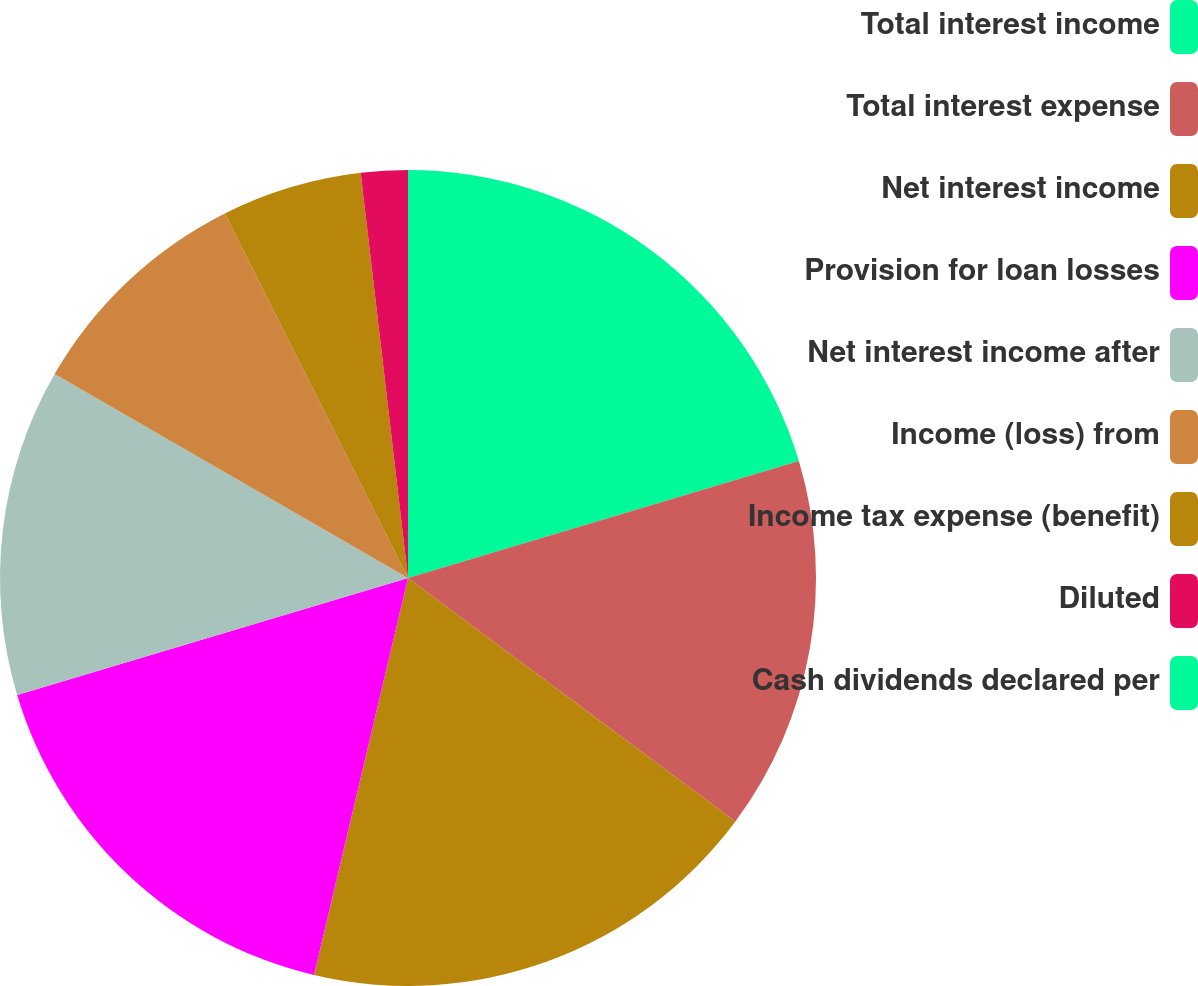Convert chart to OTSL. <chart><loc_0><loc_0><loc_500><loc_500><pie_chart><fcel>Total interest income<fcel>Total interest expense<fcel>Net interest income<fcel>Provision for loan losses<fcel>Net interest income after<fcel>Income (loss) from<fcel>Income tax expense (benefit)<fcel>Diluted<fcel>Cash dividends declared per<nl><fcel>20.37%<fcel>14.81%<fcel>18.52%<fcel>16.67%<fcel>12.96%<fcel>9.26%<fcel>5.56%<fcel>1.85%<fcel>0.0%<nl></chart> 